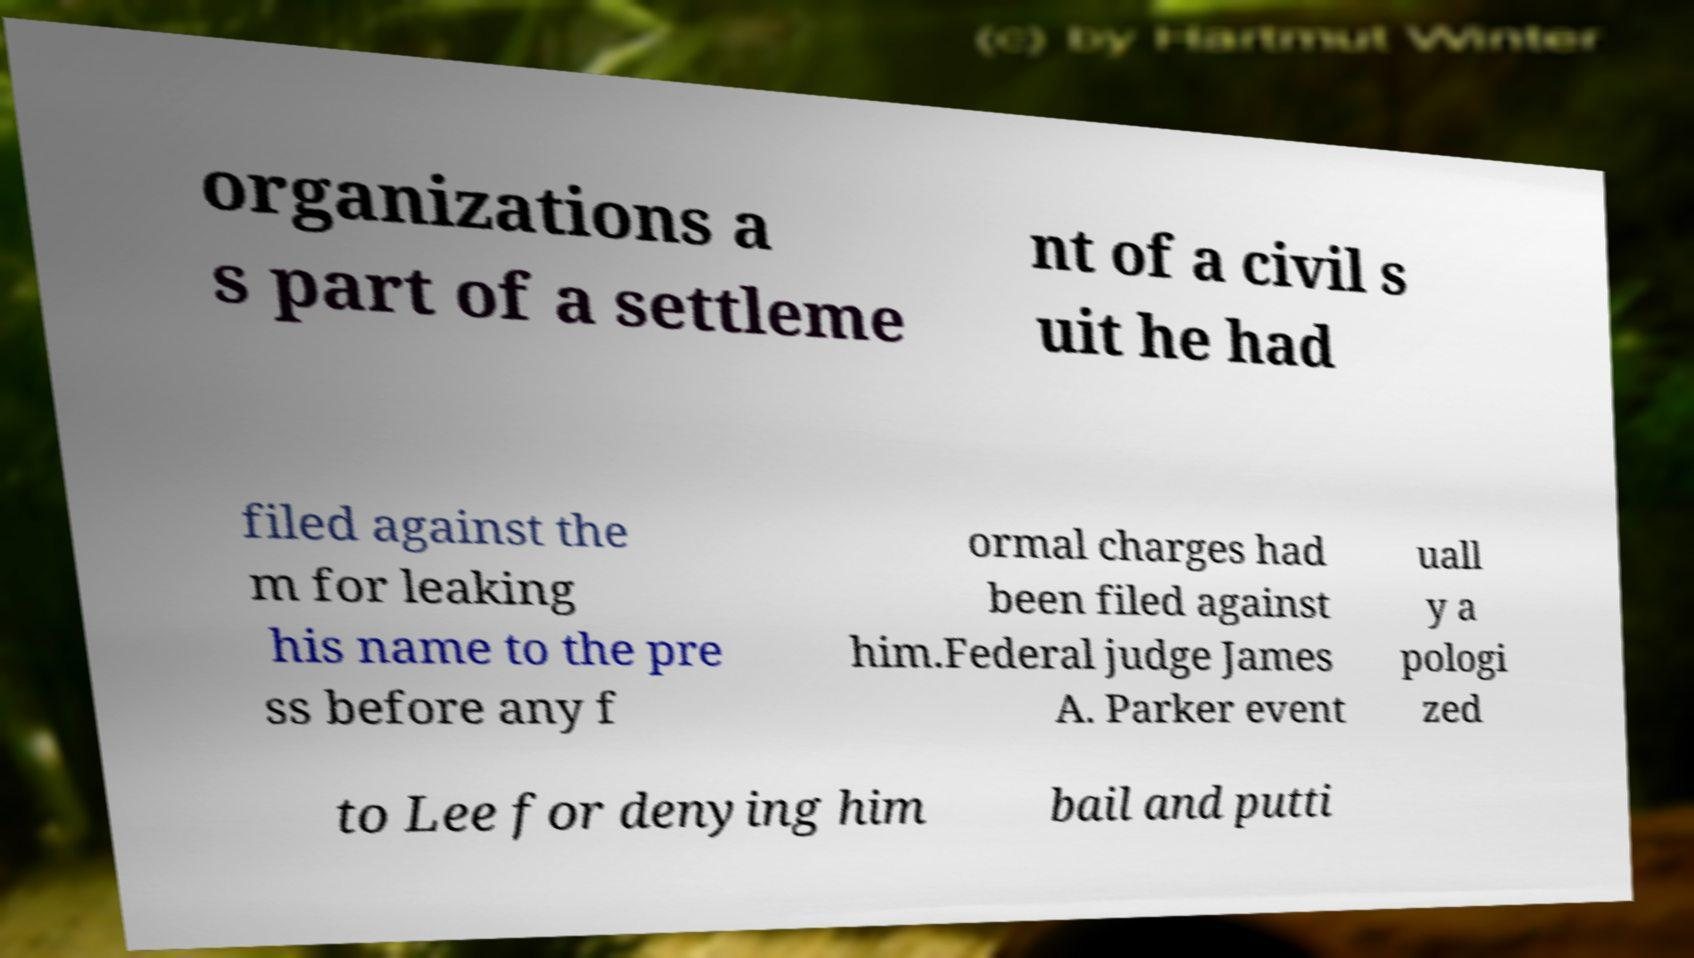Could you extract and type out the text from this image? organizations a s part of a settleme nt of a civil s uit he had filed against the m for leaking his name to the pre ss before any f ormal charges had been filed against him.Federal judge James A. Parker event uall y a pologi zed to Lee for denying him bail and putti 